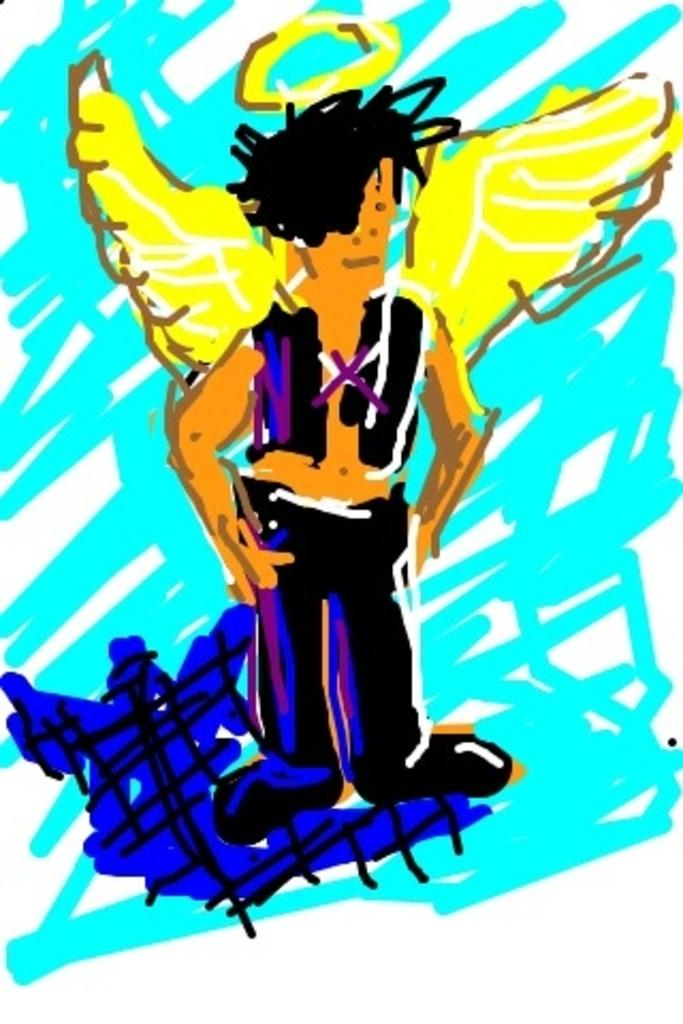What is the main subject of the image? There is a painting in the image. What does the painting depict? The painting depicts a person with wings. What type of farming equipment can be seen in the image? There is no farming equipment present in the image; it features a painting of a person with wings. Who is the creator of the painting in the image? The creator of the painting is not mentioned or visible in the image. 